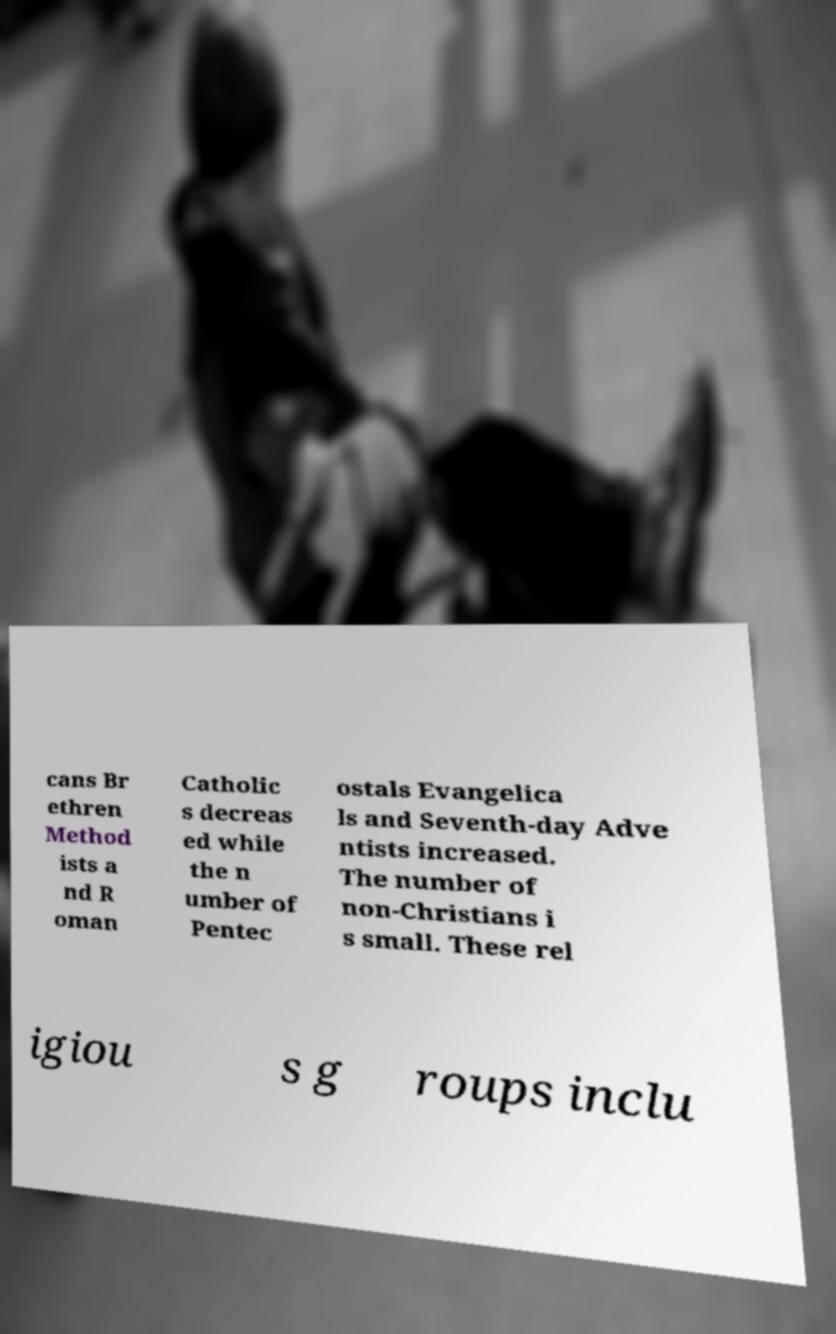Please identify and transcribe the text found in this image. cans Br ethren Method ists a nd R oman Catholic s decreas ed while the n umber of Pentec ostals Evangelica ls and Seventh-day Adve ntists increased. The number of non-Christians i s small. These rel igiou s g roups inclu 